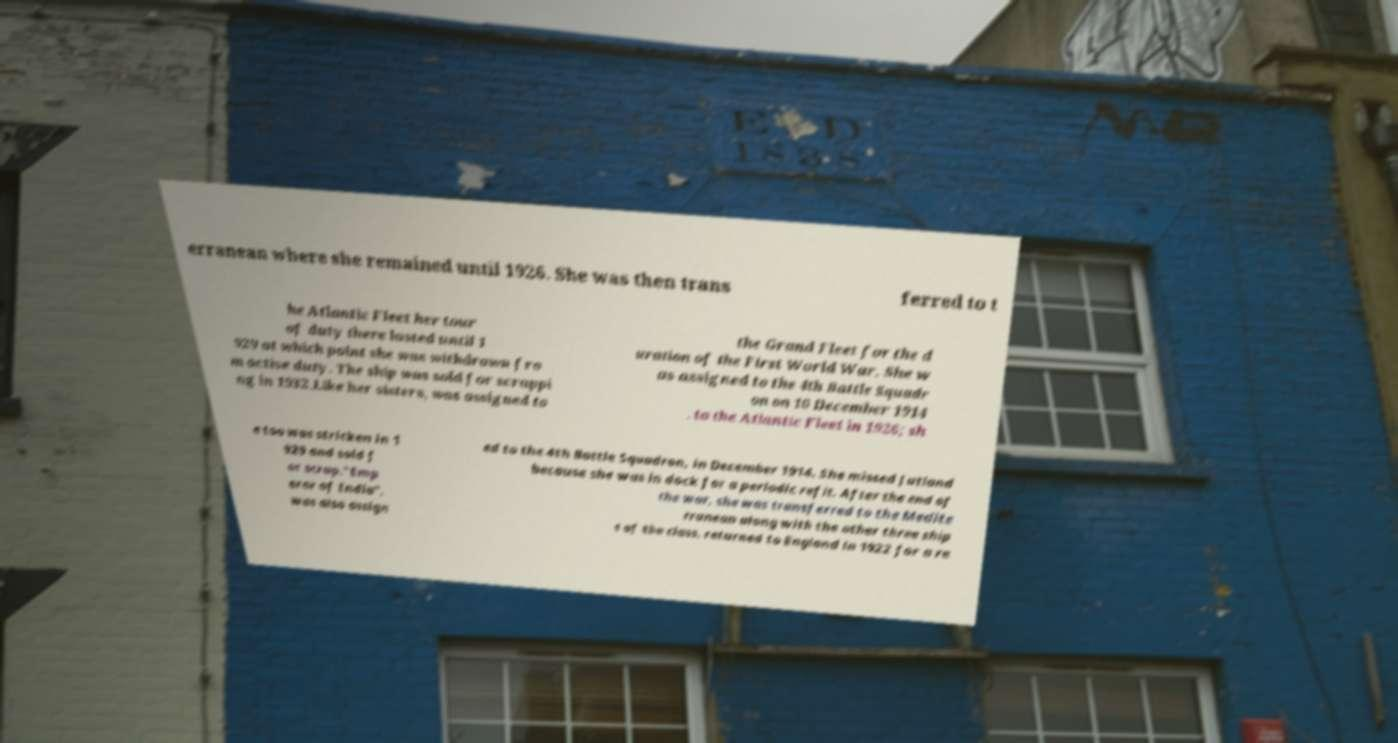Please identify and transcribe the text found in this image. erranean where she remained until 1926. She was then trans ferred to t he Atlantic Fleet her tour of duty there lasted until 1 929 at which point she was withdrawn fro m active duty. The ship was sold for scrappi ng in 1932.Like her sisters, was assigned to the Grand Fleet for the d uration of the First World War. She w as assigned to the 4th Battle Squadr on on 10 December 1914 . to the Atlantic Fleet in 1926; sh e too was stricken in 1 929 and sold f or scrap."Emp eror of India". was also assign ed to the 4th Battle Squadron, in December 1914. She missed Jutland because she was in dock for a periodic refit. After the end of the war, she was transferred to the Medite rranean along with the other three ship s of the class. returned to England in 1922 for a re 